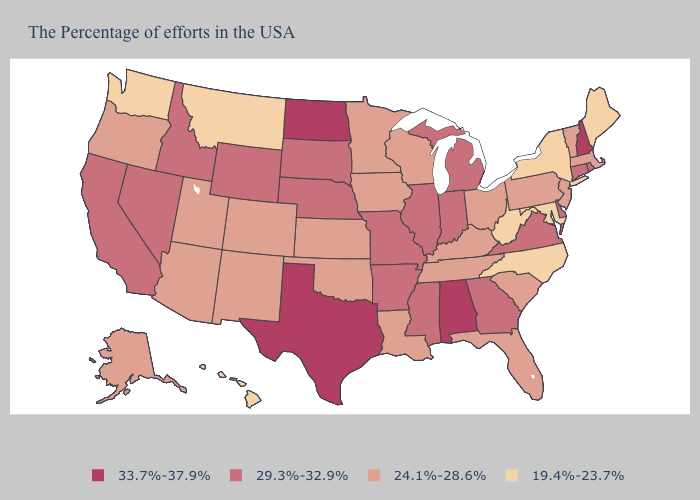Is the legend a continuous bar?
Concise answer only. No. What is the highest value in the Northeast ?
Answer briefly. 33.7%-37.9%. How many symbols are there in the legend?
Give a very brief answer. 4. What is the value of Wisconsin?
Answer briefly. 24.1%-28.6%. Is the legend a continuous bar?
Quick response, please. No. Does Alabama have the same value as North Dakota?
Be succinct. Yes. Does the first symbol in the legend represent the smallest category?
Give a very brief answer. No. Name the states that have a value in the range 29.3%-32.9%?
Answer briefly. Rhode Island, Connecticut, Delaware, Virginia, Georgia, Michigan, Indiana, Illinois, Mississippi, Missouri, Arkansas, Nebraska, South Dakota, Wyoming, Idaho, Nevada, California. Name the states that have a value in the range 19.4%-23.7%?
Answer briefly. Maine, New York, Maryland, North Carolina, West Virginia, Montana, Washington, Hawaii. What is the value of Idaho?
Quick response, please. 29.3%-32.9%. Does North Dakota have the highest value in the MidWest?
Be succinct. Yes. Does Florida have a higher value than Montana?
Concise answer only. Yes. Does Nebraska have the highest value in the MidWest?
Give a very brief answer. No. Name the states that have a value in the range 33.7%-37.9%?
Write a very short answer. New Hampshire, Alabama, Texas, North Dakota. Does South Dakota have a higher value than Texas?
Short answer required. No. 